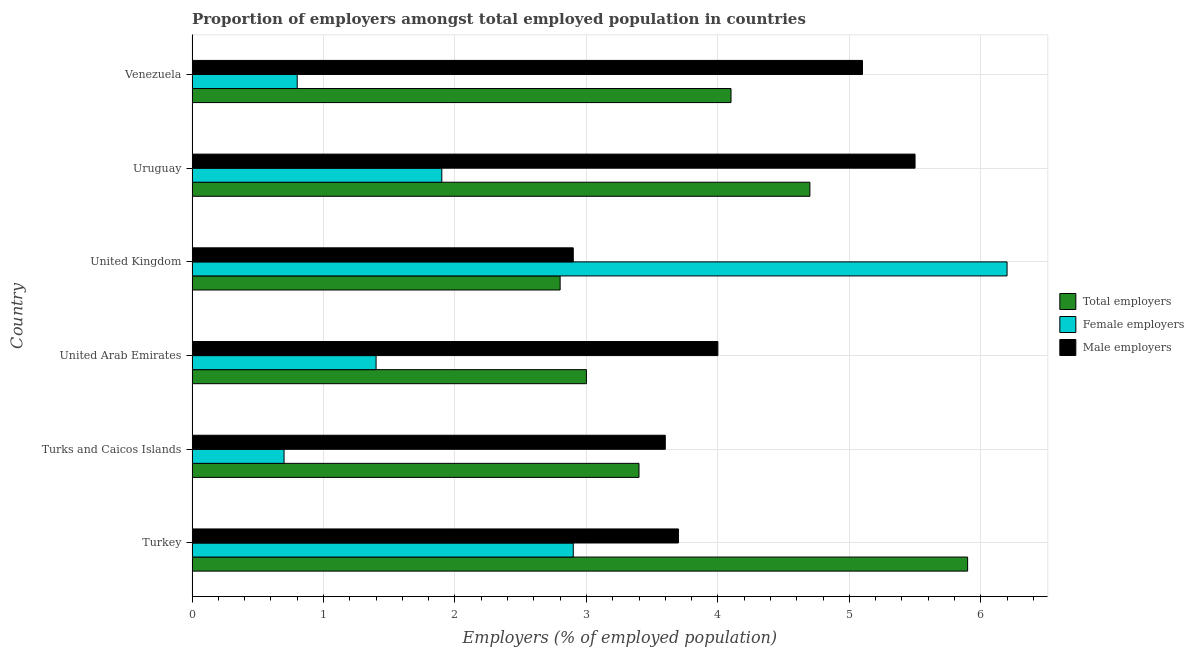How many different coloured bars are there?
Ensure brevity in your answer.  3. How many groups of bars are there?
Your response must be concise. 6. Are the number of bars per tick equal to the number of legend labels?
Offer a very short reply. Yes. How many bars are there on the 6th tick from the top?
Offer a terse response. 3. What is the label of the 2nd group of bars from the top?
Provide a short and direct response. Uruguay. What is the percentage of female employers in Turkey?
Your answer should be compact. 2.9. Across all countries, what is the maximum percentage of female employers?
Make the answer very short. 6.2. Across all countries, what is the minimum percentage of female employers?
Your response must be concise. 0.7. In which country was the percentage of female employers maximum?
Offer a terse response. United Kingdom. In which country was the percentage of female employers minimum?
Provide a succinct answer. Turks and Caicos Islands. What is the total percentage of male employers in the graph?
Ensure brevity in your answer.  24.8. What is the difference between the percentage of total employers in United Kingdom and the percentage of male employers in Venezuela?
Offer a very short reply. -2.3. What is the average percentage of total employers per country?
Make the answer very short. 3.98. What is the difference between the highest and the second highest percentage of female employers?
Your response must be concise. 3.3. What is the difference between the highest and the lowest percentage of total employers?
Provide a short and direct response. 3.1. In how many countries, is the percentage of male employers greater than the average percentage of male employers taken over all countries?
Provide a succinct answer. 2. Is the sum of the percentage of total employers in Turkey and Uruguay greater than the maximum percentage of male employers across all countries?
Keep it short and to the point. Yes. What does the 1st bar from the top in United Arab Emirates represents?
Your response must be concise. Male employers. What does the 3rd bar from the bottom in Turkey represents?
Make the answer very short. Male employers. How many bars are there?
Give a very brief answer. 18. Does the graph contain grids?
Your answer should be very brief. Yes. What is the title of the graph?
Make the answer very short. Proportion of employers amongst total employed population in countries. Does "Natural Gas" appear as one of the legend labels in the graph?
Your response must be concise. No. What is the label or title of the X-axis?
Your answer should be very brief. Employers (% of employed population). What is the Employers (% of employed population) of Total employers in Turkey?
Ensure brevity in your answer.  5.9. What is the Employers (% of employed population) of Female employers in Turkey?
Your response must be concise. 2.9. What is the Employers (% of employed population) in Male employers in Turkey?
Make the answer very short. 3.7. What is the Employers (% of employed population) of Total employers in Turks and Caicos Islands?
Ensure brevity in your answer.  3.4. What is the Employers (% of employed population) of Female employers in Turks and Caicos Islands?
Provide a short and direct response. 0.7. What is the Employers (% of employed population) of Male employers in Turks and Caicos Islands?
Offer a terse response. 3.6. What is the Employers (% of employed population) of Total employers in United Arab Emirates?
Your answer should be compact. 3. What is the Employers (% of employed population) in Female employers in United Arab Emirates?
Your response must be concise. 1.4. What is the Employers (% of employed population) in Male employers in United Arab Emirates?
Offer a very short reply. 4. What is the Employers (% of employed population) in Total employers in United Kingdom?
Keep it short and to the point. 2.8. What is the Employers (% of employed population) of Female employers in United Kingdom?
Provide a short and direct response. 6.2. What is the Employers (% of employed population) of Male employers in United Kingdom?
Offer a terse response. 2.9. What is the Employers (% of employed population) of Total employers in Uruguay?
Your response must be concise. 4.7. What is the Employers (% of employed population) of Female employers in Uruguay?
Keep it short and to the point. 1.9. What is the Employers (% of employed population) of Male employers in Uruguay?
Your response must be concise. 5.5. What is the Employers (% of employed population) in Total employers in Venezuela?
Your answer should be compact. 4.1. What is the Employers (% of employed population) of Female employers in Venezuela?
Provide a succinct answer. 0.8. What is the Employers (% of employed population) in Male employers in Venezuela?
Offer a very short reply. 5.1. Across all countries, what is the maximum Employers (% of employed population) in Total employers?
Provide a succinct answer. 5.9. Across all countries, what is the maximum Employers (% of employed population) of Female employers?
Offer a terse response. 6.2. Across all countries, what is the minimum Employers (% of employed population) in Total employers?
Offer a very short reply. 2.8. Across all countries, what is the minimum Employers (% of employed population) in Female employers?
Give a very brief answer. 0.7. Across all countries, what is the minimum Employers (% of employed population) of Male employers?
Your answer should be compact. 2.9. What is the total Employers (% of employed population) of Total employers in the graph?
Give a very brief answer. 23.9. What is the total Employers (% of employed population) in Male employers in the graph?
Provide a succinct answer. 24.8. What is the difference between the Employers (% of employed population) of Total employers in Turkey and that in Turks and Caicos Islands?
Your response must be concise. 2.5. What is the difference between the Employers (% of employed population) in Total employers in Turkey and that in United Arab Emirates?
Give a very brief answer. 2.9. What is the difference between the Employers (% of employed population) in Male employers in Turkey and that in United Arab Emirates?
Your answer should be compact. -0.3. What is the difference between the Employers (% of employed population) in Female employers in Turkey and that in United Kingdom?
Make the answer very short. -3.3. What is the difference between the Employers (% of employed population) of Total employers in Turkey and that in Uruguay?
Your answer should be very brief. 1.2. What is the difference between the Employers (% of employed population) in Male employers in Turkey and that in Uruguay?
Ensure brevity in your answer.  -1.8. What is the difference between the Employers (% of employed population) of Total employers in Turkey and that in Venezuela?
Provide a short and direct response. 1.8. What is the difference between the Employers (% of employed population) in Male employers in Turkey and that in Venezuela?
Offer a terse response. -1.4. What is the difference between the Employers (% of employed population) of Total employers in Turks and Caicos Islands and that in United Arab Emirates?
Keep it short and to the point. 0.4. What is the difference between the Employers (% of employed population) in Female employers in Turks and Caicos Islands and that in United Kingdom?
Your answer should be compact. -5.5. What is the difference between the Employers (% of employed population) of Male employers in Turks and Caicos Islands and that in United Kingdom?
Provide a short and direct response. 0.7. What is the difference between the Employers (% of employed population) of Female employers in Turks and Caicos Islands and that in Uruguay?
Make the answer very short. -1.2. What is the difference between the Employers (% of employed population) in Male employers in Turks and Caicos Islands and that in Uruguay?
Provide a succinct answer. -1.9. What is the difference between the Employers (% of employed population) of Total employers in Turks and Caicos Islands and that in Venezuela?
Provide a succinct answer. -0.7. What is the difference between the Employers (% of employed population) of Male employers in Turks and Caicos Islands and that in Venezuela?
Keep it short and to the point. -1.5. What is the difference between the Employers (% of employed population) in Total employers in United Arab Emirates and that in United Kingdom?
Ensure brevity in your answer.  0.2. What is the difference between the Employers (% of employed population) of Total employers in United Arab Emirates and that in Uruguay?
Keep it short and to the point. -1.7. What is the difference between the Employers (% of employed population) in Female employers in United Arab Emirates and that in Uruguay?
Provide a succinct answer. -0.5. What is the difference between the Employers (% of employed population) in Female employers in United Kingdom and that in Uruguay?
Offer a very short reply. 4.3. What is the difference between the Employers (% of employed population) in Male employers in United Kingdom and that in Uruguay?
Offer a terse response. -2.6. What is the difference between the Employers (% of employed population) in Female employers in United Kingdom and that in Venezuela?
Offer a very short reply. 5.4. What is the difference between the Employers (% of employed population) in Male employers in United Kingdom and that in Venezuela?
Offer a terse response. -2.2. What is the difference between the Employers (% of employed population) in Female employers in Uruguay and that in Venezuela?
Make the answer very short. 1.1. What is the difference between the Employers (% of employed population) of Male employers in Uruguay and that in Venezuela?
Provide a short and direct response. 0.4. What is the difference between the Employers (% of employed population) in Total employers in Turkey and the Employers (% of employed population) in Female employers in Turks and Caicos Islands?
Give a very brief answer. 5.2. What is the difference between the Employers (% of employed population) in Total employers in Turkey and the Employers (% of employed population) in Male employers in Turks and Caicos Islands?
Offer a terse response. 2.3. What is the difference between the Employers (% of employed population) in Total employers in Turkey and the Employers (% of employed population) in Male employers in United Arab Emirates?
Make the answer very short. 1.9. What is the difference between the Employers (% of employed population) in Total employers in Turkey and the Employers (% of employed population) in Male employers in United Kingdom?
Give a very brief answer. 3. What is the difference between the Employers (% of employed population) in Female employers in Turkey and the Employers (% of employed population) in Male employers in United Kingdom?
Provide a succinct answer. 0. What is the difference between the Employers (% of employed population) of Female employers in Turkey and the Employers (% of employed population) of Male employers in Uruguay?
Keep it short and to the point. -2.6. What is the difference between the Employers (% of employed population) of Total employers in Turkey and the Employers (% of employed population) of Female employers in Venezuela?
Offer a terse response. 5.1. What is the difference between the Employers (% of employed population) of Total employers in Turkey and the Employers (% of employed population) of Male employers in Venezuela?
Give a very brief answer. 0.8. What is the difference between the Employers (% of employed population) in Female employers in Turkey and the Employers (% of employed population) in Male employers in Venezuela?
Ensure brevity in your answer.  -2.2. What is the difference between the Employers (% of employed population) in Total employers in Turks and Caicos Islands and the Employers (% of employed population) in Male employers in United Arab Emirates?
Your answer should be compact. -0.6. What is the difference between the Employers (% of employed population) in Female employers in Turks and Caicos Islands and the Employers (% of employed population) in Male employers in United Arab Emirates?
Keep it short and to the point. -3.3. What is the difference between the Employers (% of employed population) in Total employers in Turks and Caicos Islands and the Employers (% of employed population) in Female employers in Uruguay?
Provide a succinct answer. 1.5. What is the difference between the Employers (% of employed population) of Total employers in Turks and Caicos Islands and the Employers (% of employed population) of Female employers in Venezuela?
Give a very brief answer. 2.6. What is the difference between the Employers (% of employed population) in Total employers in United Arab Emirates and the Employers (% of employed population) in Female employers in United Kingdom?
Give a very brief answer. -3.2. What is the difference between the Employers (% of employed population) in Total employers in United Arab Emirates and the Employers (% of employed population) in Male employers in United Kingdom?
Ensure brevity in your answer.  0.1. What is the difference between the Employers (% of employed population) in Total employers in United Arab Emirates and the Employers (% of employed population) in Female employers in Uruguay?
Your response must be concise. 1.1. What is the difference between the Employers (% of employed population) in Total employers in United Arab Emirates and the Employers (% of employed population) in Male employers in Uruguay?
Your answer should be compact. -2.5. What is the difference between the Employers (% of employed population) in Female employers in United Arab Emirates and the Employers (% of employed population) in Male employers in Uruguay?
Provide a short and direct response. -4.1. What is the difference between the Employers (% of employed population) of Total employers in United Arab Emirates and the Employers (% of employed population) of Female employers in Venezuela?
Make the answer very short. 2.2. What is the difference between the Employers (% of employed population) of Total employers in United Arab Emirates and the Employers (% of employed population) of Male employers in Venezuela?
Your answer should be very brief. -2.1. What is the difference between the Employers (% of employed population) of Female employers in United Arab Emirates and the Employers (% of employed population) of Male employers in Venezuela?
Offer a terse response. -3.7. What is the difference between the Employers (% of employed population) in Total employers in United Kingdom and the Employers (% of employed population) in Female employers in Uruguay?
Offer a very short reply. 0.9. What is the difference between the Employers (% of employed population) in Total employers in United Kingdom and the Employers (% of employed population) in Female employers in Venezuela?
Keep it short and to the point. 2. What is the difference between the Employers (% of employed population) in Total employers in United Kingdom and the Employers (% of employed population) in Male employers in Venezuela?
Keep it short and to the point. -2.3. What is the difference between the Employers (% of employed population) in Total employers in Uruguay and the Employers (% of employed population) in Female employers in Venezuela?
Give a very brief answer. 3.9. What is the difference between the Employers (% of employed population) of Total employers in Uruguay and the Employers (% of employed population) of Male employers in Venezuela?
Give a very brief answer. -0.4. What is the difference between the Employers (% of employed population) of Female employers in Uruguay and the Employers (% of employed population) of Male employers in Venezuela?
Your answer should be compact. -3.2. What is the average Employers (% of employed population) of Total employers per country?
Your answer should be very brief. 3.98. What is the average Employers (% of employed population) of Female employers per country?
Offer a terse response. 2.32. What is the average Employers (% of employed population) in Male employers per country?
Ensure brevity in your answer.  4.13. What is the difference between the Employers (% of employed population) of Total employers and Employers (% of employed population) of Male employers in Turkey?
Offer a very short reply. 2.2. What is the difference between the Employers (% of employed population) in Female employers and Employers (% of employed population) in Male employers in Turkey?
Give a very brief answer. -0.8. What is the difference between the Employers (% of employed population) in Total employers and Employers (% of employed population) in Male employers in Turks and Caicos Islands?
Your answer should be compact. -0.2. What is the difference between the Employers (% of employed population) of Female employers and Employers (% of employed population) of Male employers in Turks and Caicos Islands?
Your answer should be compact. -2.9. What is the difference between the Employers (% of employed population) of Total employers and Employers (% of employed population) of Male employers in United Arab Emirates?
Your response must be concise. -1. What is the difference between the Employers (% of employed population) of Total employers and Employers (% of employed population) of Male employers in United Kingdom?
Your answer should be compact. -0.1. What is the difference between the Employers (% of employed population) in Female employers and Employers (% of employed population) in Male employers in United Kingdom?
Your answer should be very brief. 3.3. What is the difference between the Employers (% of employed population) of Female employers and Employers (% of employed population) of Male employers in Uruguay?
Ensure brevity in your answer.  -3.6. What is the difference between the Employers (% of employed population) in Total employers and Employers (% of employed population) in Male employers in Venezuela?
Your response must be concise. -1. What is the ratio of the Employers (% of employed population) of Total employers in Turkey to that in Turks and Caicos Islands?
Your answer should be compact. 1.74. What is the ratio of the Employers (% of employed population) of Female employers in Turkey to that in Turks and Caicos Islands?
Give a very brief answer. 4.14. What is the ratio of the Employers (% of employed population) of Male employers in Turkey to that in Turks and Caicos Islands?
Make the answer very short. 1.03. What is the ratio of the Employers (% of employed population) in Total employers in Turkey to that in United Arab Emirates?
Ensure brevity in your answer.  1.97. What is the ratio of the Employers (% of employed population) of Female employers in Turkey to that in United Arab Emirates?
Ensure brevity in your answer.  2.07. What is the ratio of the Employers (% of employed population) in Male employers in Turkey to that in United Arab Emirates?
Provide a succinct answer. 0.93. What is the ratio of the Employers (% of employed population) of Total employers in Turkey to that in United Kingdom?
Provide a short and direct response. 2.11. What is the ratio of the Employers (% of employed population) of Female employers in Turkey to that in United Kingdom?
Keep it short and to the point. 0.47. What is the ratio of the Employers (% of employed population) of Male employers in Turkey to that in United Kingdom?
Your response must be concise. 1.28. What is the ratio of the Employers (% of employed population) of Total employers in Turkey to that in Uruguay?
Your response must be concise. 1.26. What is the ratio of the Employers (% of employed population) in Female employers in Turkey to that in Uruguay?
Give a very brief answer. 1.53. What is the ratio of the Employers (% of employed population) of Male employers in Turkey to that in Uruguay?
Make the answer very short. 0.67. What is the ratio of the Employers (% of employed population) in Total employers in Turkey to that in Venezuela?
Your response must be concise. 1.44. What is the ratio of the Employers (% of employed population) of Female employers in Turkey to that in Venezuela?
Your answer should be very brief. 3.62. What is the ratio of the Employers (% of employed population) in Male employers in Turkey to that in Venezuela?
Ensure brevity in your answer.  0.73. What is the ratio of the Employers (% of employed population) in Total employers in Turks and Caicos Islands to that in United Arab Emirates?
Give a very brief answer. 1.13. What is the ratio of the Employers (% of employed population) in Total employers in Turks and Caicos Islands to that in United Kingdom?
Offer a very short reply. 1.21. What is the ratio of the Employers (% of employed population) in Female employers in Turks and Caicos Islands to that in United Kingdom?
Give a very brief answer. 0.11. What is the ratio of the Employers (% of employed population) of Male employers in Turks and Caicos Islands to that in United Kingdom?
Your response must be concise. 1.24. What is the ratio of the Employers (% of employed population) of Total employers in Turks and Caicos Islands to that in Uruguay?
Give a very brief answer. 0.72. What is the ratio of the Employers (% of employed population) in Female employers in Turks and Caicos Islands to that in Uruguay?
Offer a very short reply. 0.37. What is the ratio of the Employers (% of employed population) in Male employers in Turks and Caicos Islands to that in Uruguay?
Your answer should be compact. 0.65. What is the ratio of the Employers (% of employed population) of Total employers in Turks and Caicos Islands to that in Venezuela?
Your answer should be very brief. 0.83. What is the ratio of the Employers (% of employed population) of Male employers in Turks and Caicos Islands to that in Venezuela?
Your answer should be very brief. 0.71. What is the ratio of the Employers (% of employed population) in Total employers in United Arab Emirates to that in United Kingdom?
Make the answer very short. 1.07. What is the ratio of the Employers (% of employed population) of Female employers in United Arab Emirates to that in United Kingdom?
Give a very brief answer. 0.23. What is the ratio of the Employers (% of employed population) in Male employers in United Arab Emirates to that in United Kingdom?
Offer a terse response. 1.38. What is the ratio of the Employers (% of employed population) in Total employers in United Arab Emirates to that in Uruguay?
Your answer should be very brief. 0.64. What is the ratio of the Employers (% of employed population) of Female employers in United Arab Emirates to that in Uruguay?
Ensure brevity in your answer.  0.74. What is the ratio of the Employers (% of employed population) in Male employers in United Arab Emirates to that in Uruguay?
Your response must be concise. 0.73. What is the ratio of the Employers (% of employed population) of Total employers in United Arab Emirates to that in Venezuela?
Keep it short and to the point. 0.73. What is the ratio of the Employers (% of employed population) of Female employers in United Arab Emirates to that in Venezuela?
Provide a short and direct response. 1.75. What is the ratio of the Employers (% of employed population) of Male employers in United Arab Emirates to that in Venezuela?
Keep it short and to the point. 0.78. What is the ratio of the Employers (% of employed population) of Total employers in United Kingdom to that in Uruguay?
Ensure brevity in your answer.  0.6. What is the ratio of the Employers (% of employed population) in Female employers in United Kingdom to that in Uruguay?
Provide a short and direct response. 3.26. What is the ratio of the Employers (% of employed population) in Male employers in United Kingdom to that in Uruguay?
Provide a succinct answer. 0.53. What is the ratio of the Employers (% of employed population) of Total employers in United Kingdom to that in Venezuela?
Keep it short and to the point. 0.68. What is the ratio of the Employers (% of employed population) of Female employers in United Kingdom to that in Venezuela?
Offer a terse response. 7.75. What is the ratio of the Employers (% of employed population) of Male employers in United Kingdom to that in Venezuela?
Provide a short and direct response. 0.57. What is the ratio of the Employers (% of employed population) of Total employers in Uruguay to that in Venezuela?
Give a very brief answer. 1.15. What is the ratio of the Employers (% of employed population) of Female employers in Uruguay to that in Venezuela?
Provide a succinct answer. 2.38. What is the ratio of the Employers (% of employed population) of Male employers in Uruguay to that in Venezuela?
Your response must be concise. 1.08. What is the difference between the highest and the second highest Employers (% of employed population) in Total employers?
Give a very brief answer. 1.2. What is the difference between the highest and the second highest Employers (% of employed population) in Male employers?
Offer a very short reply. 0.4. What is the difference between the highest and the lowest Employers (% of employed population) in Female employers?
Offer a very short reply. 5.5. What is the difference between the highest and the lowest Employers (% of employed population) in Male employers?
Offer a terse response. 2.6. 